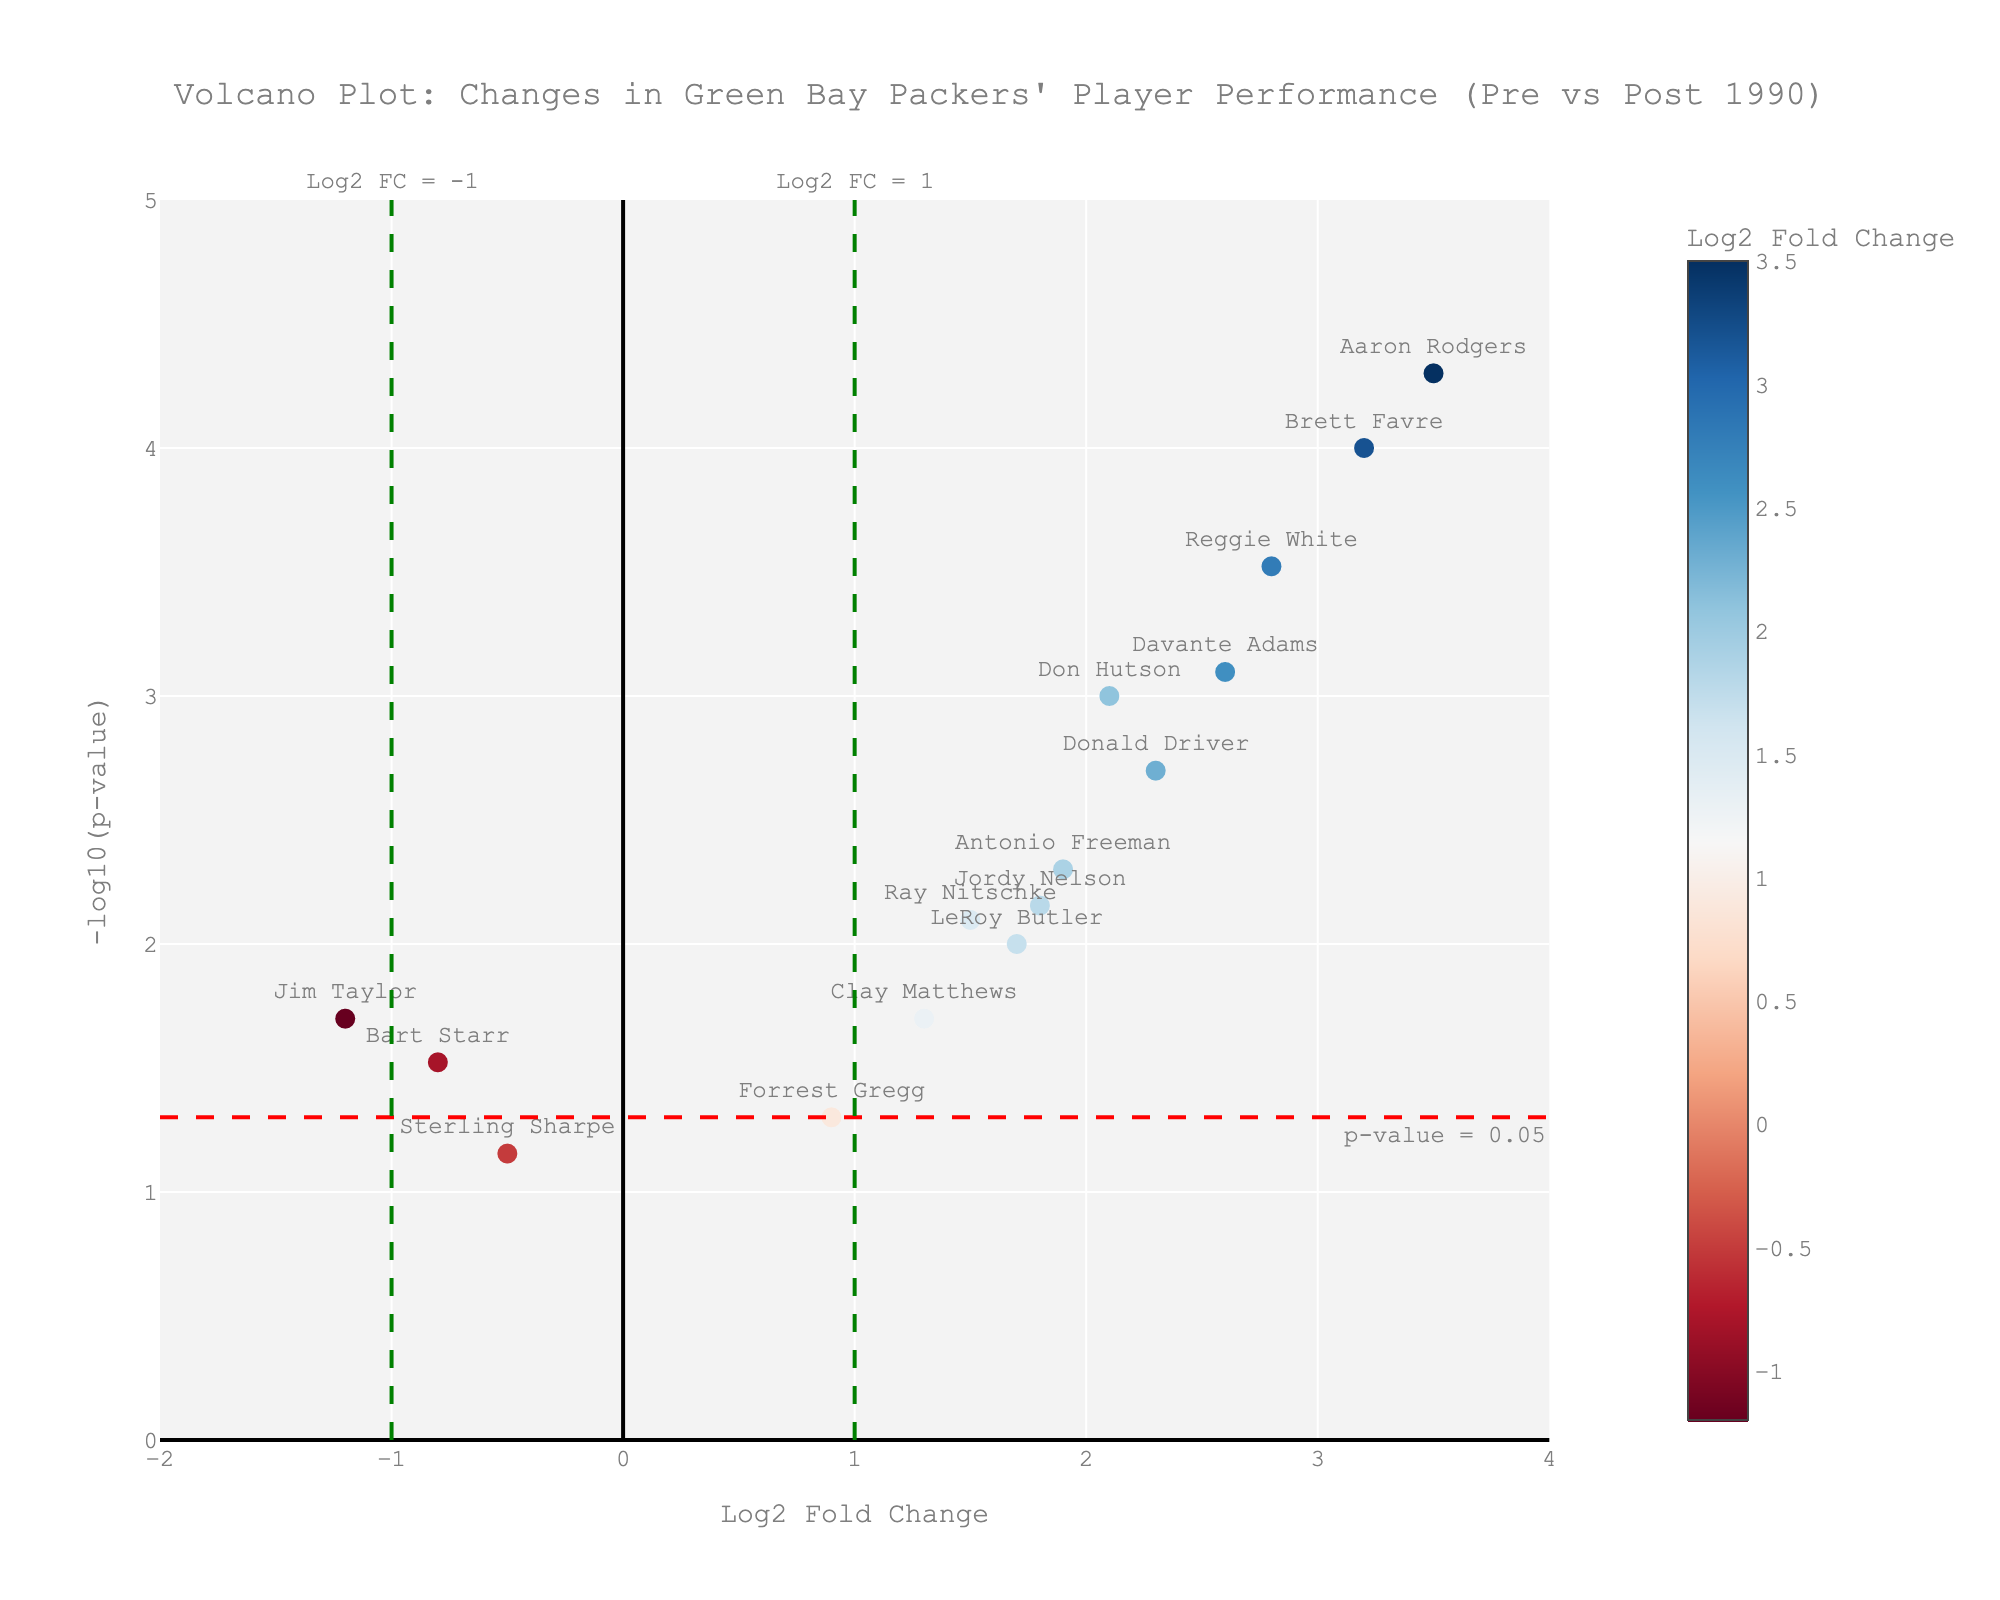How many players have a Log2 Fold Change greater than 1? By visually inspecting the x-axis, count the number of players whose Log2 Fold Change values are greater than 1. These points are to the right of the vertical line at x = 1.
Answer: 8 Who has the highest Log2 Fold Change? Look for the point farthest to the right on the x-axis. The player’s name associated with this point indicates the highest Log2 Fold Change.
Answer: Aaron Rodgers Which player has the lowest Log2 Fold Change? Look for the point farthest to the left on the x-axis. The player’s name associated with this point indicates the lowest Log2 Fold Change.
Answer: Jim Taylor How many players have statistically significant changes (p-value > 0.05)? Check for points above the horizontal red dashed line which represents p-value = 0.05. Count the number of points above this line.
Answer: 11 Between Bart Starr and Brett Favre, who has a lower p-value? Compare the positions on the y-axis of the points associated with Bart Starr and Brett Favre. The higher the point on the y-axis, the lower the p-value.
Answer: Brett Favre What is the range of the Log2 Fold Change values? Find the difference between the maximum and minimum values on the x-axis. The maximum is 3.5 (Aaron Rodgers) and the minimum is -1.2 (Jim Taylor).
Answer: 4.7 Are there any players with a Log2 Fold Change near zero? Look for points close to the vertical line at x = 0. Identify any player names that are near this line.
Answer: No, none are near zero Which three players have the highest -log10(p-value) values? Identify the three highest points on the y-axis and note the player names associated with these points.
Answer: Aaron Rodgers, Brett Favre, Reggie White What color represents a positive Log2 Fold Change in the plot? Observe the color scale on the right side of the plot. Positive Log2 Fold Change values are represented by colors on the color scale from zero to higher positive values.
Answer: Shades of blue Is there a clear threshold for significant changes marked on the plot? Look for horizontal and vertical lines that indicate thresholds. The red horizontal dashed line and green vertical dashed lines mark such thresholds for significant changes in Log2 Fold Change.
Answer: Yes 